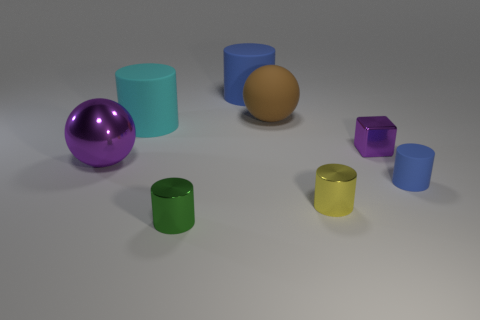There is a big cyan rubber object; how many purple things are on the left side of it?
Offer a very short reply. 1. How many small rubber cylinders are the same color as the small matte thing?
Offer a very short reply. 0. Is the material of the blue cylinder in front of the big blue matte cylinder the same as the big blue cylinder?
Give a very brief answer. Yes. How many tiny purple cylinders are the same material as the yellow object?
Offer a terse response. 0. Are there more large objects that are behind the small purple shiny thing than large purple metallic spheres?
Provide a succinct answer. Yes. There is a cube that is the same color as the metal ball; what size is it?
Provide a succinct answer. Small. Is there a green object that has the same shape as the large cyan matte thing?
Provide a succinct answer. Yes. What number of objects are either small cyan blocks or yellow shiny objects?
Provide a succinct answer. 1. There is a blue cylinder that is behind the tiny metallic object that is behind the large purple metallic object; what number of brown matte balls are behind it?
Keep it short and to the point. 0. What is the material of the tiny blue object that is the same shape as the small green shiny object?
Offer a terse response. Rubber. 